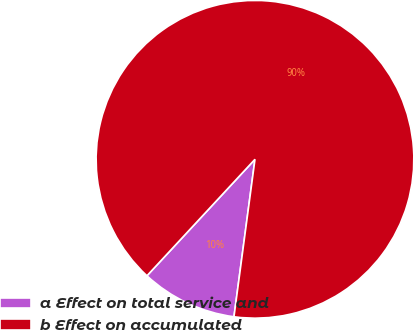Convert chart to OTSL. <chart><loc_0><loc_0><loc_500><loc_500><pie_chart><fcel>a Effect on total service and<fcel>b Effect on accumulated<nl><fcel>9.79%<fcel>90.21%<nl></chart> 